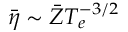<formula> <loc_0><loc_0><loc_500><loc_500>\bar { \eta } \sim \bar { Z } T _ { e } ^ { - 3 / 2 }</formula> 